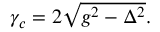Convert formula to latex. <formula><loc_0><loc_0><loc_500><loc_500>\begin{array} { r } { \gamma _ { c } = 2 \sqrt { g ^ { 2 } - \Delta ^ { 2 } } . } \end{array}</formula> 